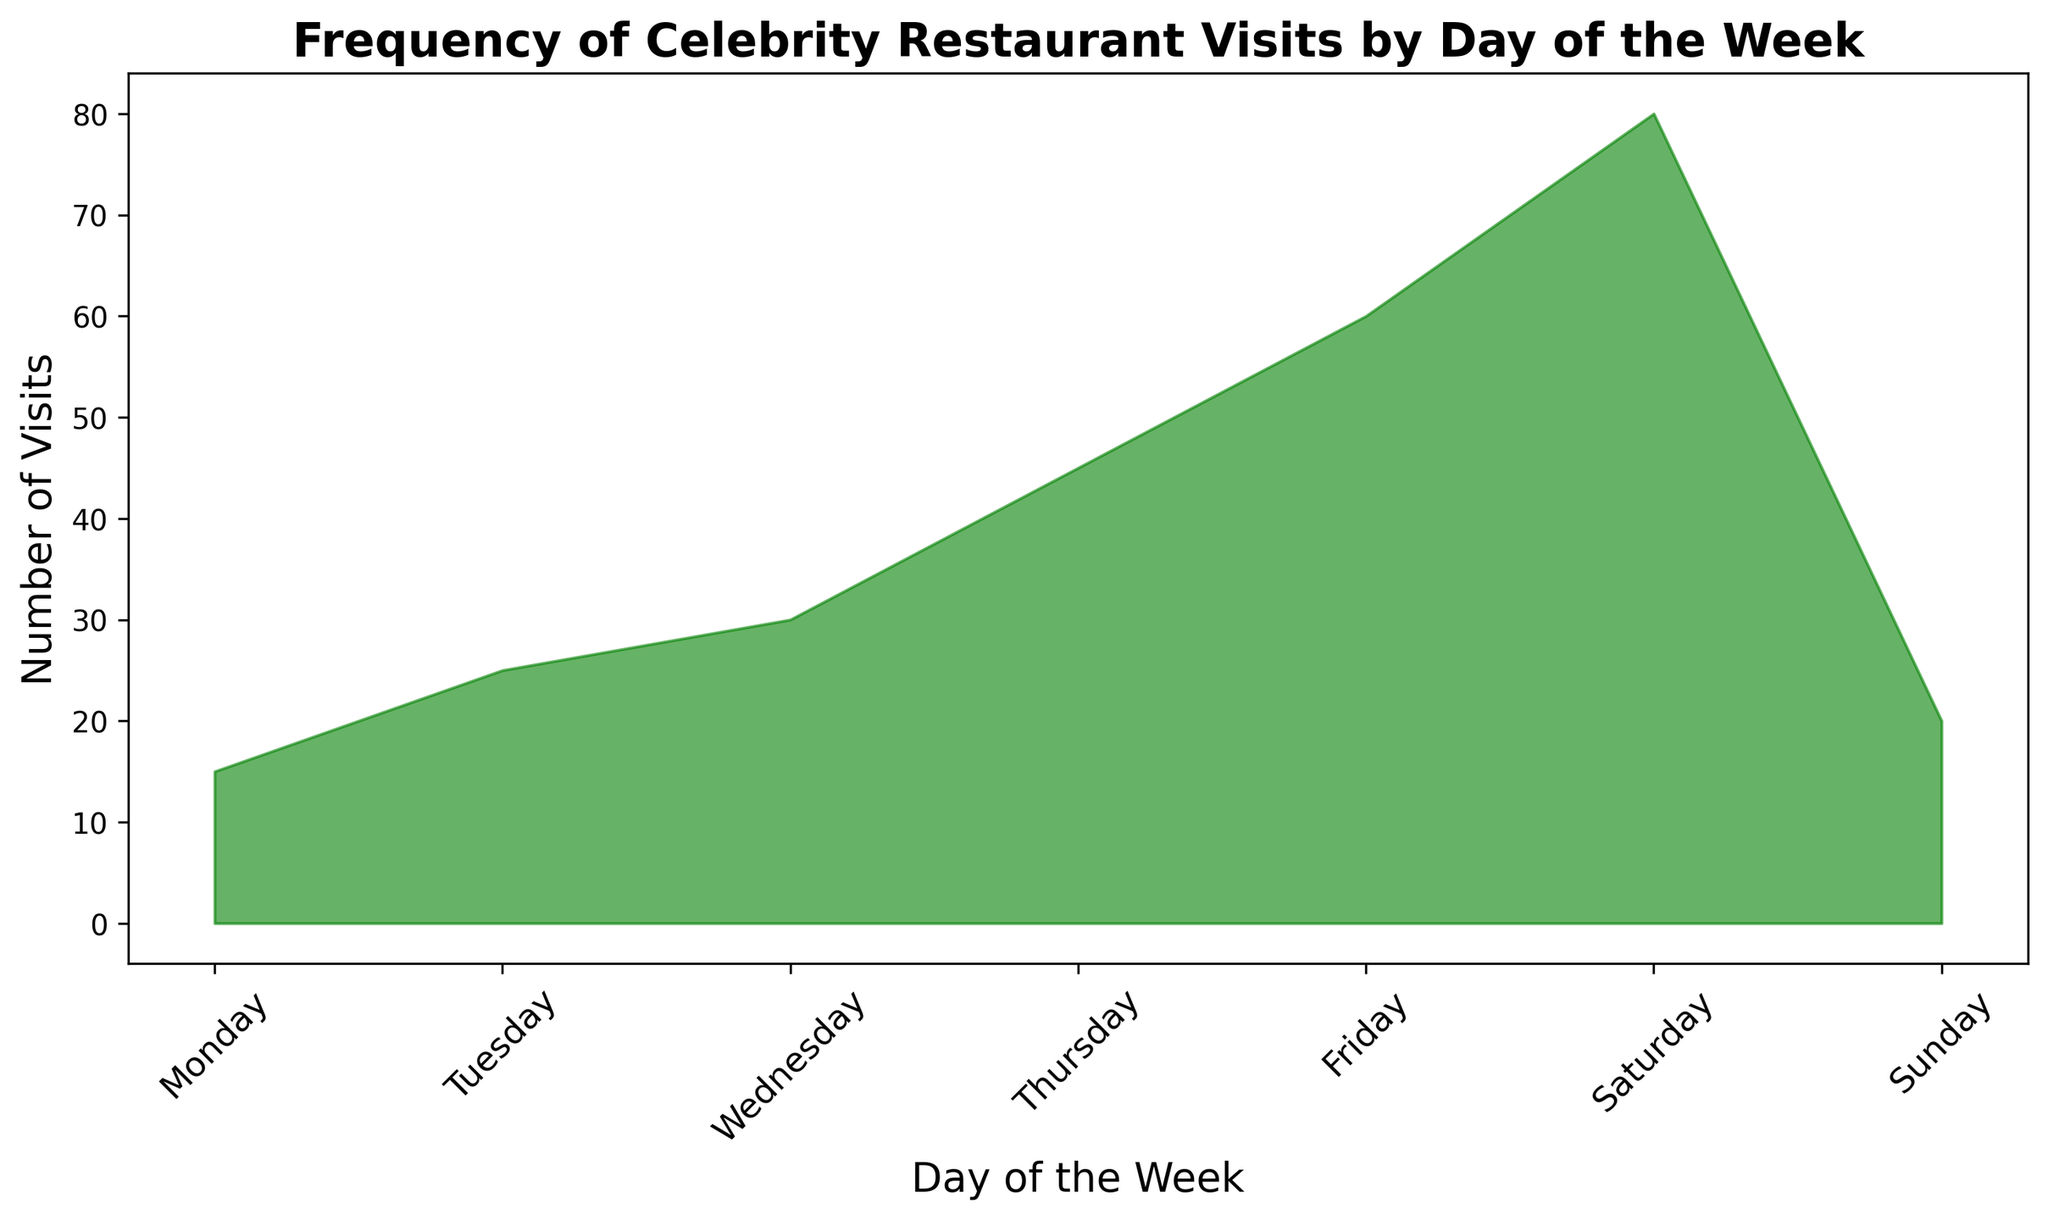What's the total number of celebrity visits for the weekend (Saturday and Sunday)? To find the total number of visits for the weekend, sum the values for Saturday and Sunday. From the chart, Saturday has 80 visits, and Sunday has 20 visits. So, 80 + 20 = 100.
Answer: 100 Which day of the week has the highest number of celebrity visits? Observe the area chart to identify the day with the tallest peak. Friday and Saturday both have the highest peaks, but Saturday is slightly taller. Hence, Saturday has the highest number of visits with 80.
Answer: Saturday How many more visits are there on Friday compared to Sunday? Compare the number of visits on Friday and Sunday. Friday has 60 visits while Sunday has 20. Subtract the number of visits on Sunday from the number on Friday: 60 - 20 = 40.
Answer: 40 What's the average number of visits from Monday to Wednesday? Calculate the average by summing the visits from Monday, Tuesday, and Wednesday and dividing by 3. The visits are 15, 25, and 30 respectively. Thus, (15 + 25 + 30) / 3 = 70 / 3 ≈ 23.33.
Answer: 23.33 Which day of the week shows an increasing trend in visits compared to its previous day? Examine the area chart to see which days have a higher number of visits than the previous day. Notably, each consecutive day from Monday to Saturday shows an increase. For a concise answer, Thursday (45) is higher than Wednesday (30).
Answer: These include Tuesday, Wednesday, Thursday, Friday, and Saturday What's the difference in number of visits between the day with the highest and the day with the lowest visits? The day with the highest visits is Saturday (80) and the lowest is Monday (15). Subtract the number of visits on Monday from Saturday: 80 - 15 = 65.
Answer: 65 How many more visits are there on Saturday compared to Monday and Tuesday combined? Calculate the total visits on Monday and Tuesday (15 + 25 = 40) and compare with Saturday (80). Then, subtract: 80 - 40 = 40.
Answer: 40 Which two consecutive days have the smallest increase in the number of visits? Identify the smallest difference between visits on two consecutive days. Monday (15) to Tuesday (25) has the smallest increase: 25 - 15 = 10.
Answer: Monday to Tuesday What’s the average number of visits for the weekdays (Monday to Friday)? Sum the visits from Monday to Friday (15, 25, 30, 45, and 60) and divide by 5. The total is 175, so the average is 175 / 5 = 35.
Answer: 35 